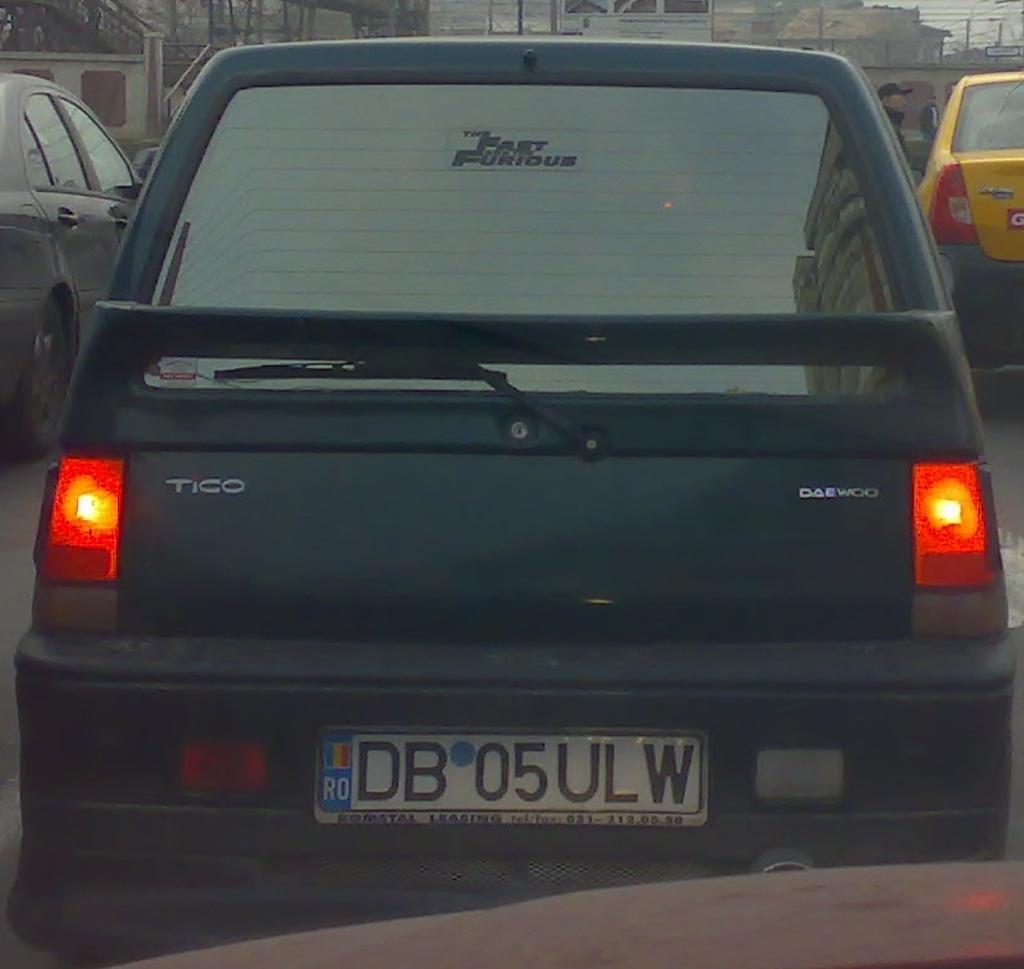What is the model name of this daewoo?
Your answer should be compact. Tico. 